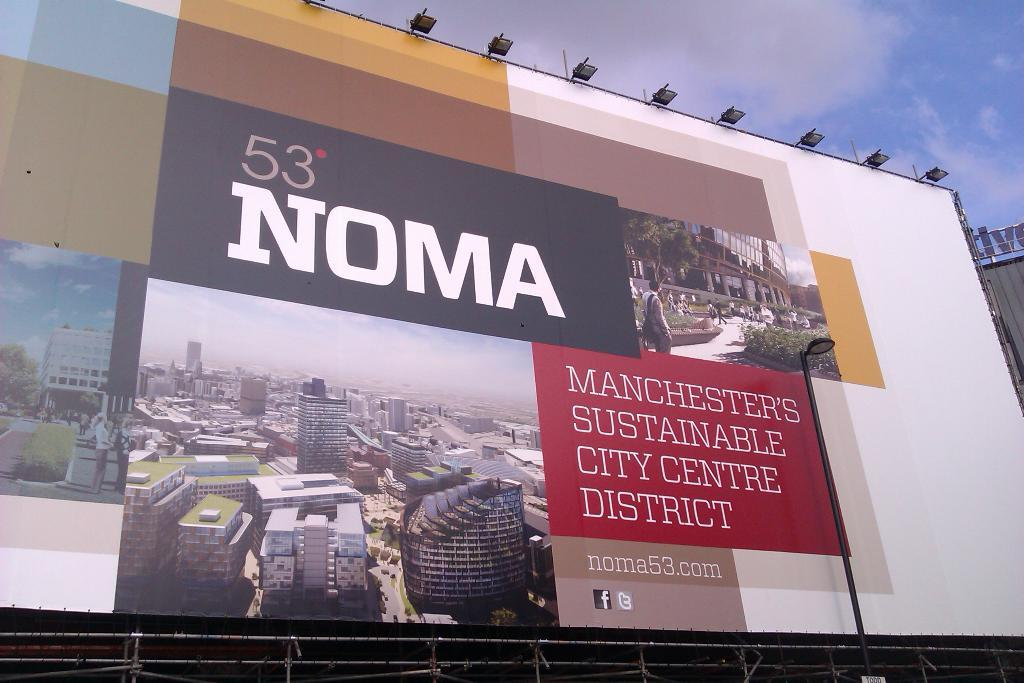<image>
Write a terse but informative summary of the picture. A large sign located outdoors advertising a new district named  "53 Noma" 